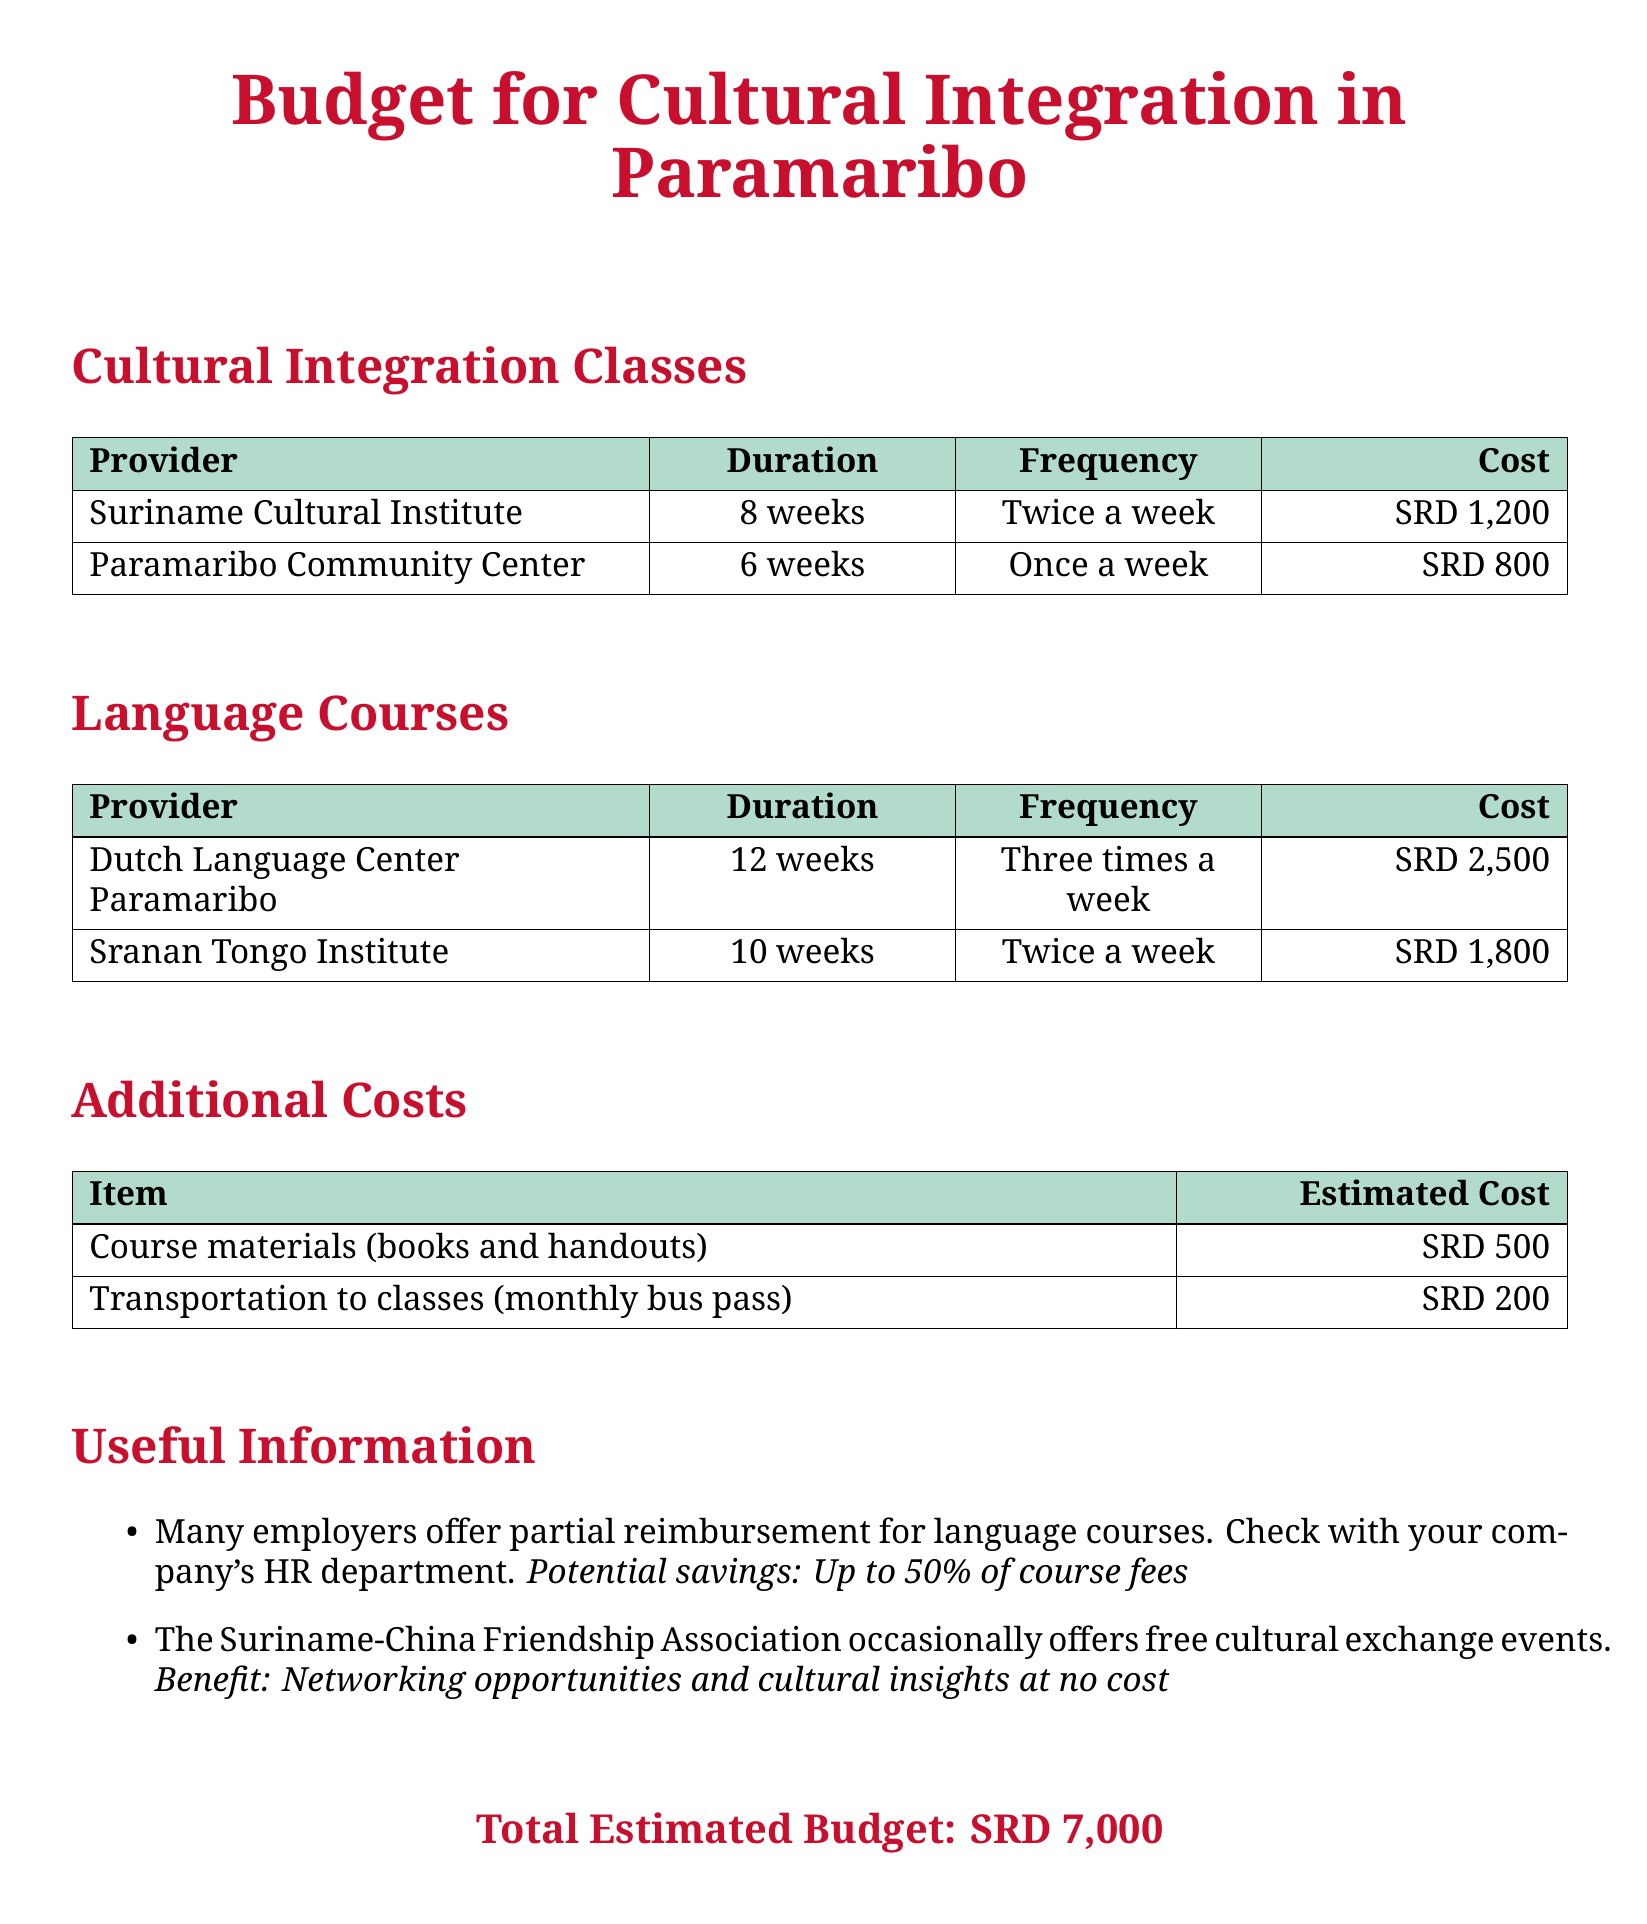What is the total estimated budget? The total estimated budget is stated clearly at the end of the document.
Answer: SRD 7,000 How long is the course at the Paramaribo Community Center? The duration for the course is mentioned in the table under Cultural Integration Classes.
Answer: 6 weeks What is the cost of the Dutch Language Center Paramaribo course? The cost is listed in the Language Courses section of the document.
Answer: SRD 2,500 How many weeks does the Sranan Tongo Institute course last? The duration for this course is found in the table under Language Courses.
Answer: 10 weeks What is the frequency of classes at the Suriname Cultural Institute? The frequency of classes is indicated in the same section where the provider's name and cost are found.
Answer: Twice a week What is the estimated cost for transportation to classes? The document lists additional costs, including transportation, in the Additional Costs section.
Answer: SRD 200 Which institute offers a course for learning Dutch? The document explicitly names the institute that offers Dutch language courses under Language Courses.
Answer: Dutch Language Center Paramaribo What is the benefit of the Suriname-China Friendship Association? This benefit is mentioned in the Useful Information section regarding cultural exchange.
Answer: Networking opportunities How much is allocated for course materials? The estimated cost for course materials is detailed in the Additional Costs section of the document.
Answer: SRD 500 